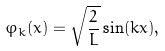<formula> <loc_0><loc_0><loc_500><loc_500>\varphi _ { k } ( x ) = \sqrt { \frac { 2 } { L } } \sin ( k x ) ,</formula> 